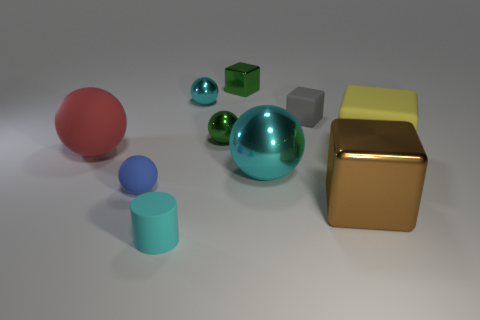Subtract 1 balls. How many balls are left? 4 Subtract all small matte balls. How many balls are left? 4 Subtract all purple spheres. Subtract all cyan cylinders. How many spheres are left? 5 Subtract all cylinders. How many objects are left? 9 Subtract 0 red cylinders. How many objects are left? 10 Subtract all gray things. Subtract all tiny matte objects. How many objects are left? 6 Add 8 big red things. How many big red things are left? 9 Add 4 big brown rubber cubes. How many big brown rubber cubes exist? 4 